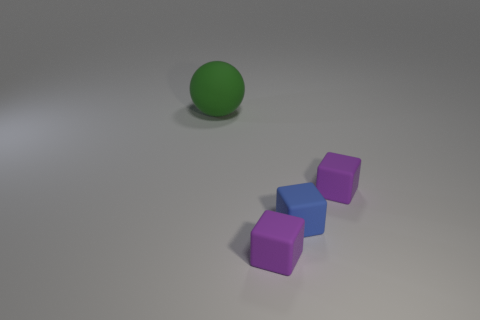Add 3 small purple matte cubes. How many objects exist? 7 Subtract all blocks. How many objects are left? 1 Add 3 cubes. How many cubes exist? 6 Subtract 0 gray cylinders. How many objects are left? 4 Subtract all large purple shiny things. Subtract all small cubes. How many objects are left? 1 Add 4 small blue things. How many small blue things are left? 5 